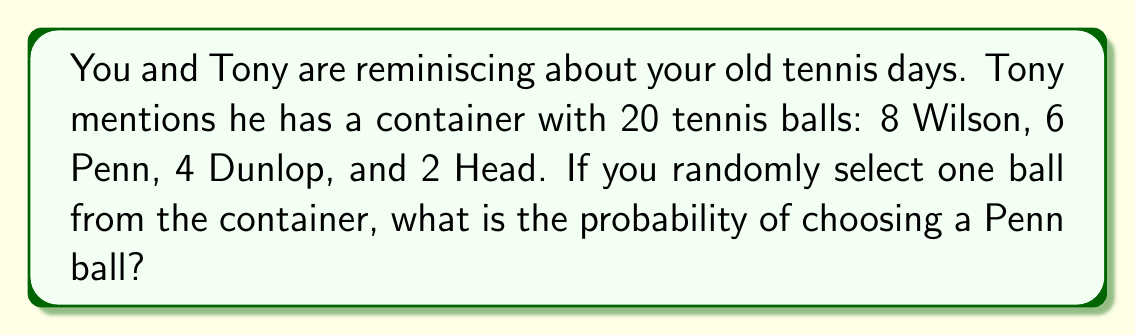What is the answer to this math problem? Let's approach this step-by-step:

1) First, we need to identify the total number of outcomes (total number of tennis balls) and the number of favorable outcomes (number of Penn balls):

   Total balls: $20$
   Penn balls: $6$

2) The probability of an event is calculated by dividing the number of favorable outcomes by the total number of possible outcomes:

   $$P(\text{Penn ball}) = \frac{\text{Number of Penn balls}}{\text{Total number of balls}}$$

3) Substituting our values:

   $$P(\text{Penn ball}) = \frac{6}{20}$$

4) This fraction can be simplified by dividing both numerator and denominator by their greatest common divisor (GCD), which is 2:

   $$P(\text{Penn ball}) = \frac{6 \div 2}{20 \div 2} = \frac{3}{10}$$

5) Therefore, the probability of selecting a Penn ball is $\frac{3}{10}$ or $0.3$ or $30\%$.
Answer: $\frac{3}{10}$ 